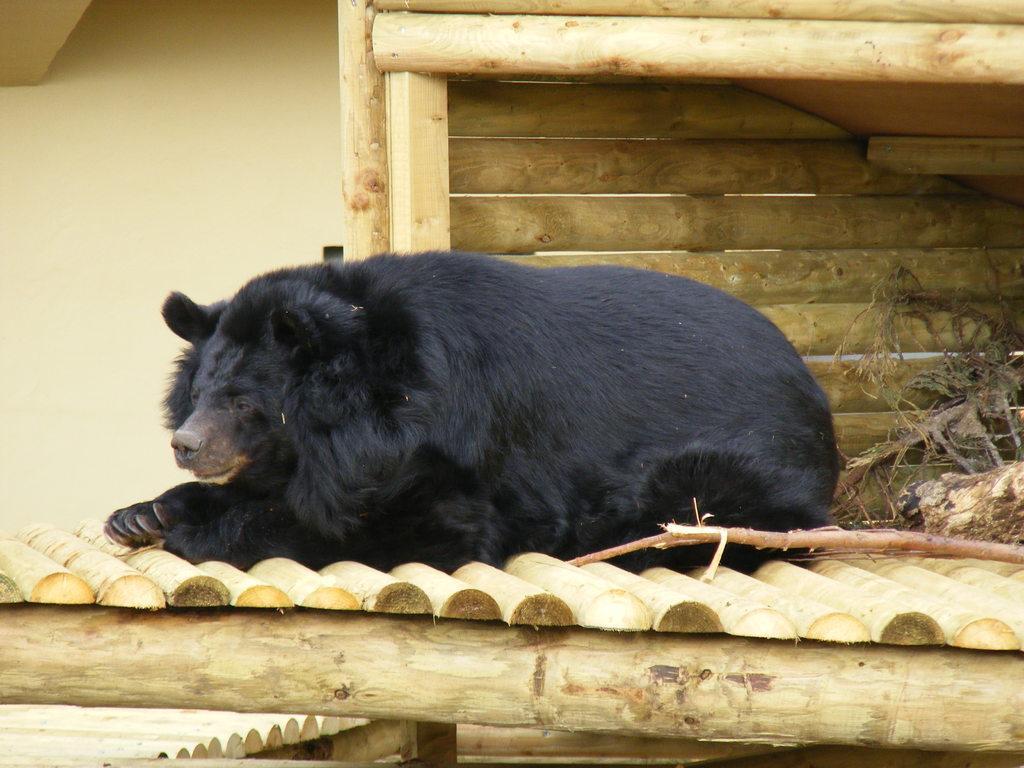In one or two sentences, can you explain what this image depicts? In this image I can see the wooden surface which is brown and cream in color and on it I can see an animal which is black and brown in color is lying. In the background I can see the cream colored wall and a shed which is made of wooden logs. 